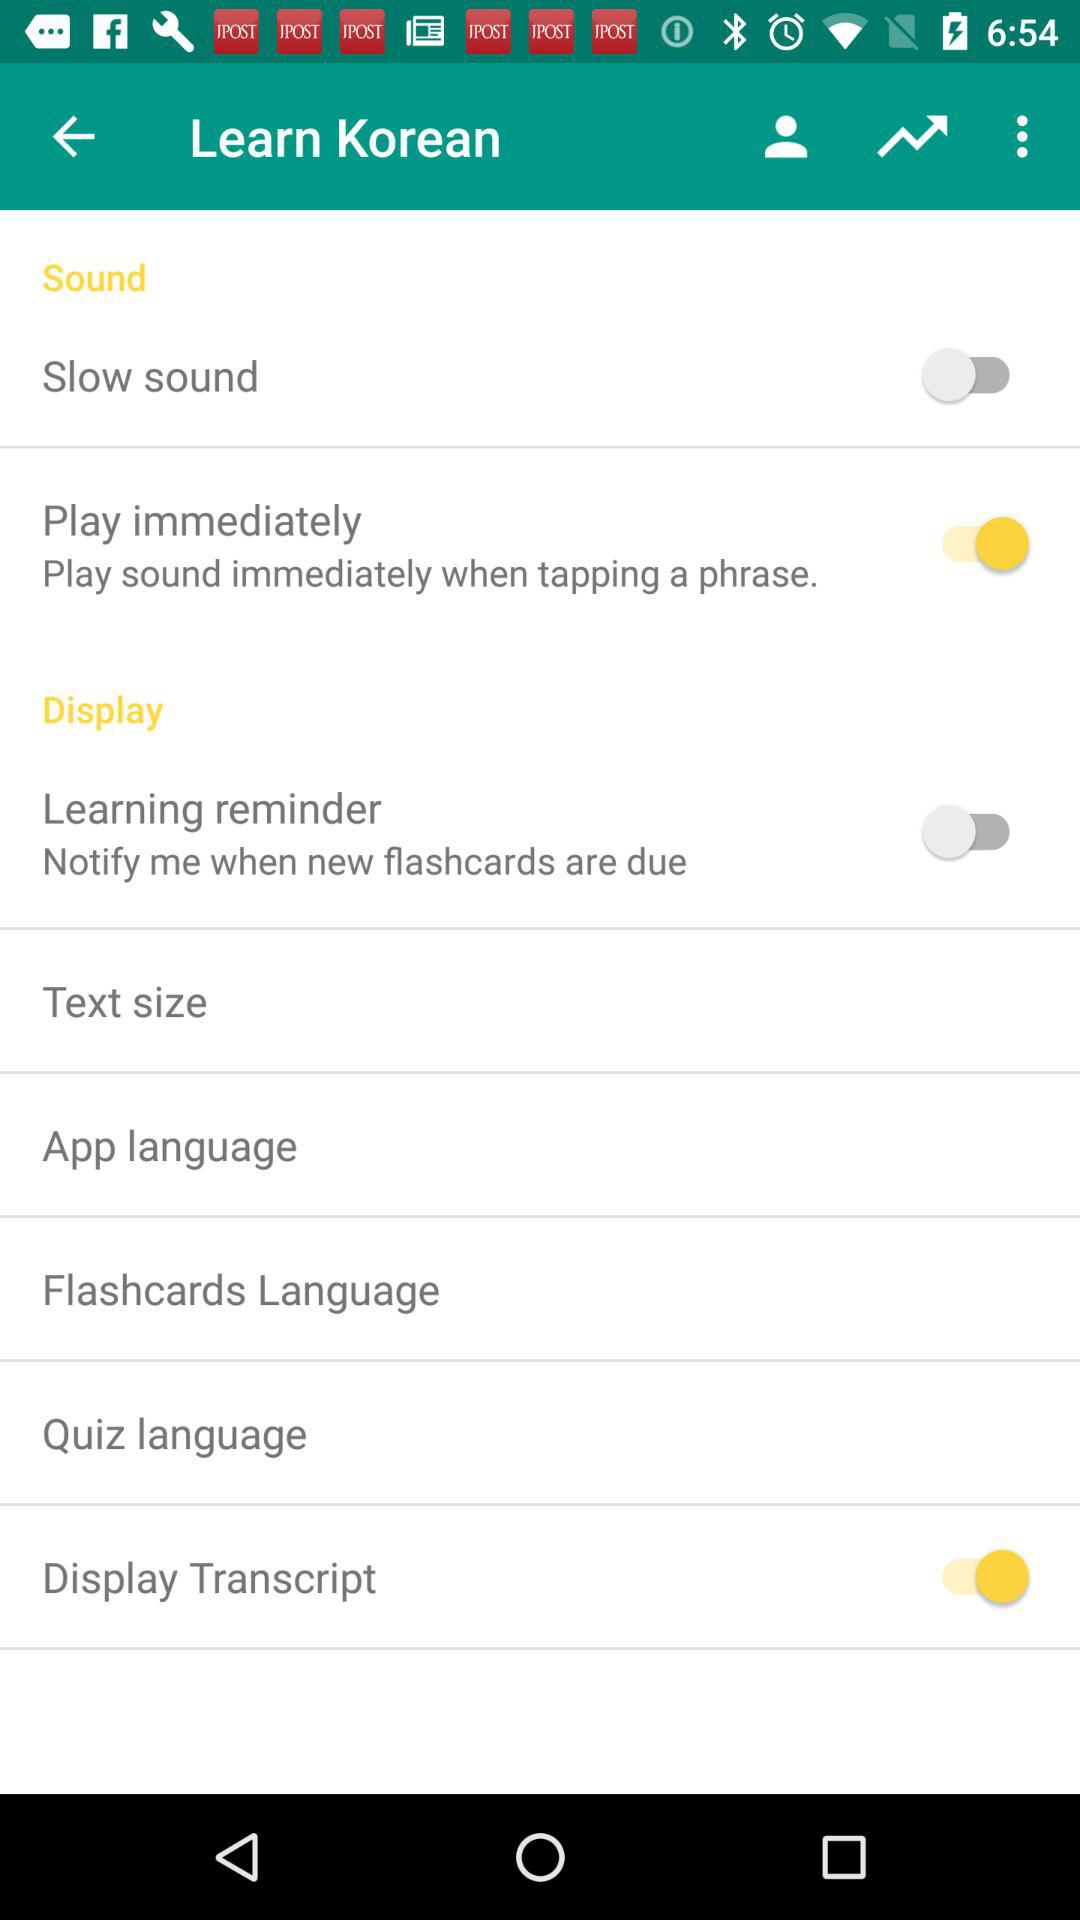What is the status of "Display Transcript"? The status is "on". 